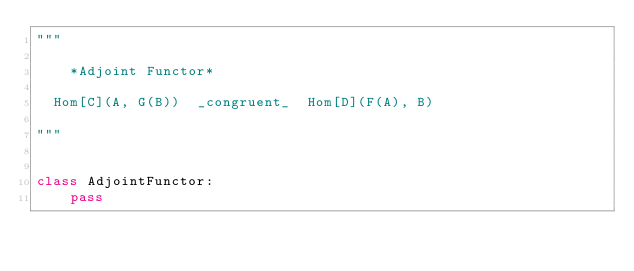Convert code to text. <code><loc_0><loc_0><loc_500><loc_500><_Python_>"""

    *Adjoint Functor*

  Hom[C](A, G(B))  _congruent_  Hom[D](F(A), B)

"""


class AdjointFunctor:
    pass
</code> 